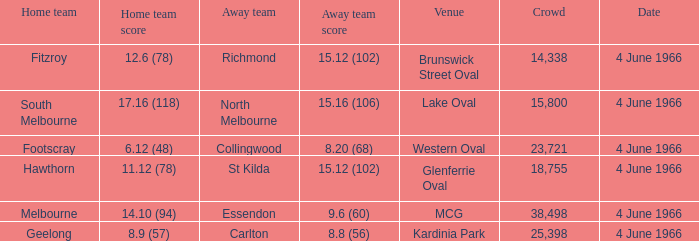What is the score of the away team that played home team Geelong? 8.8 (56). 